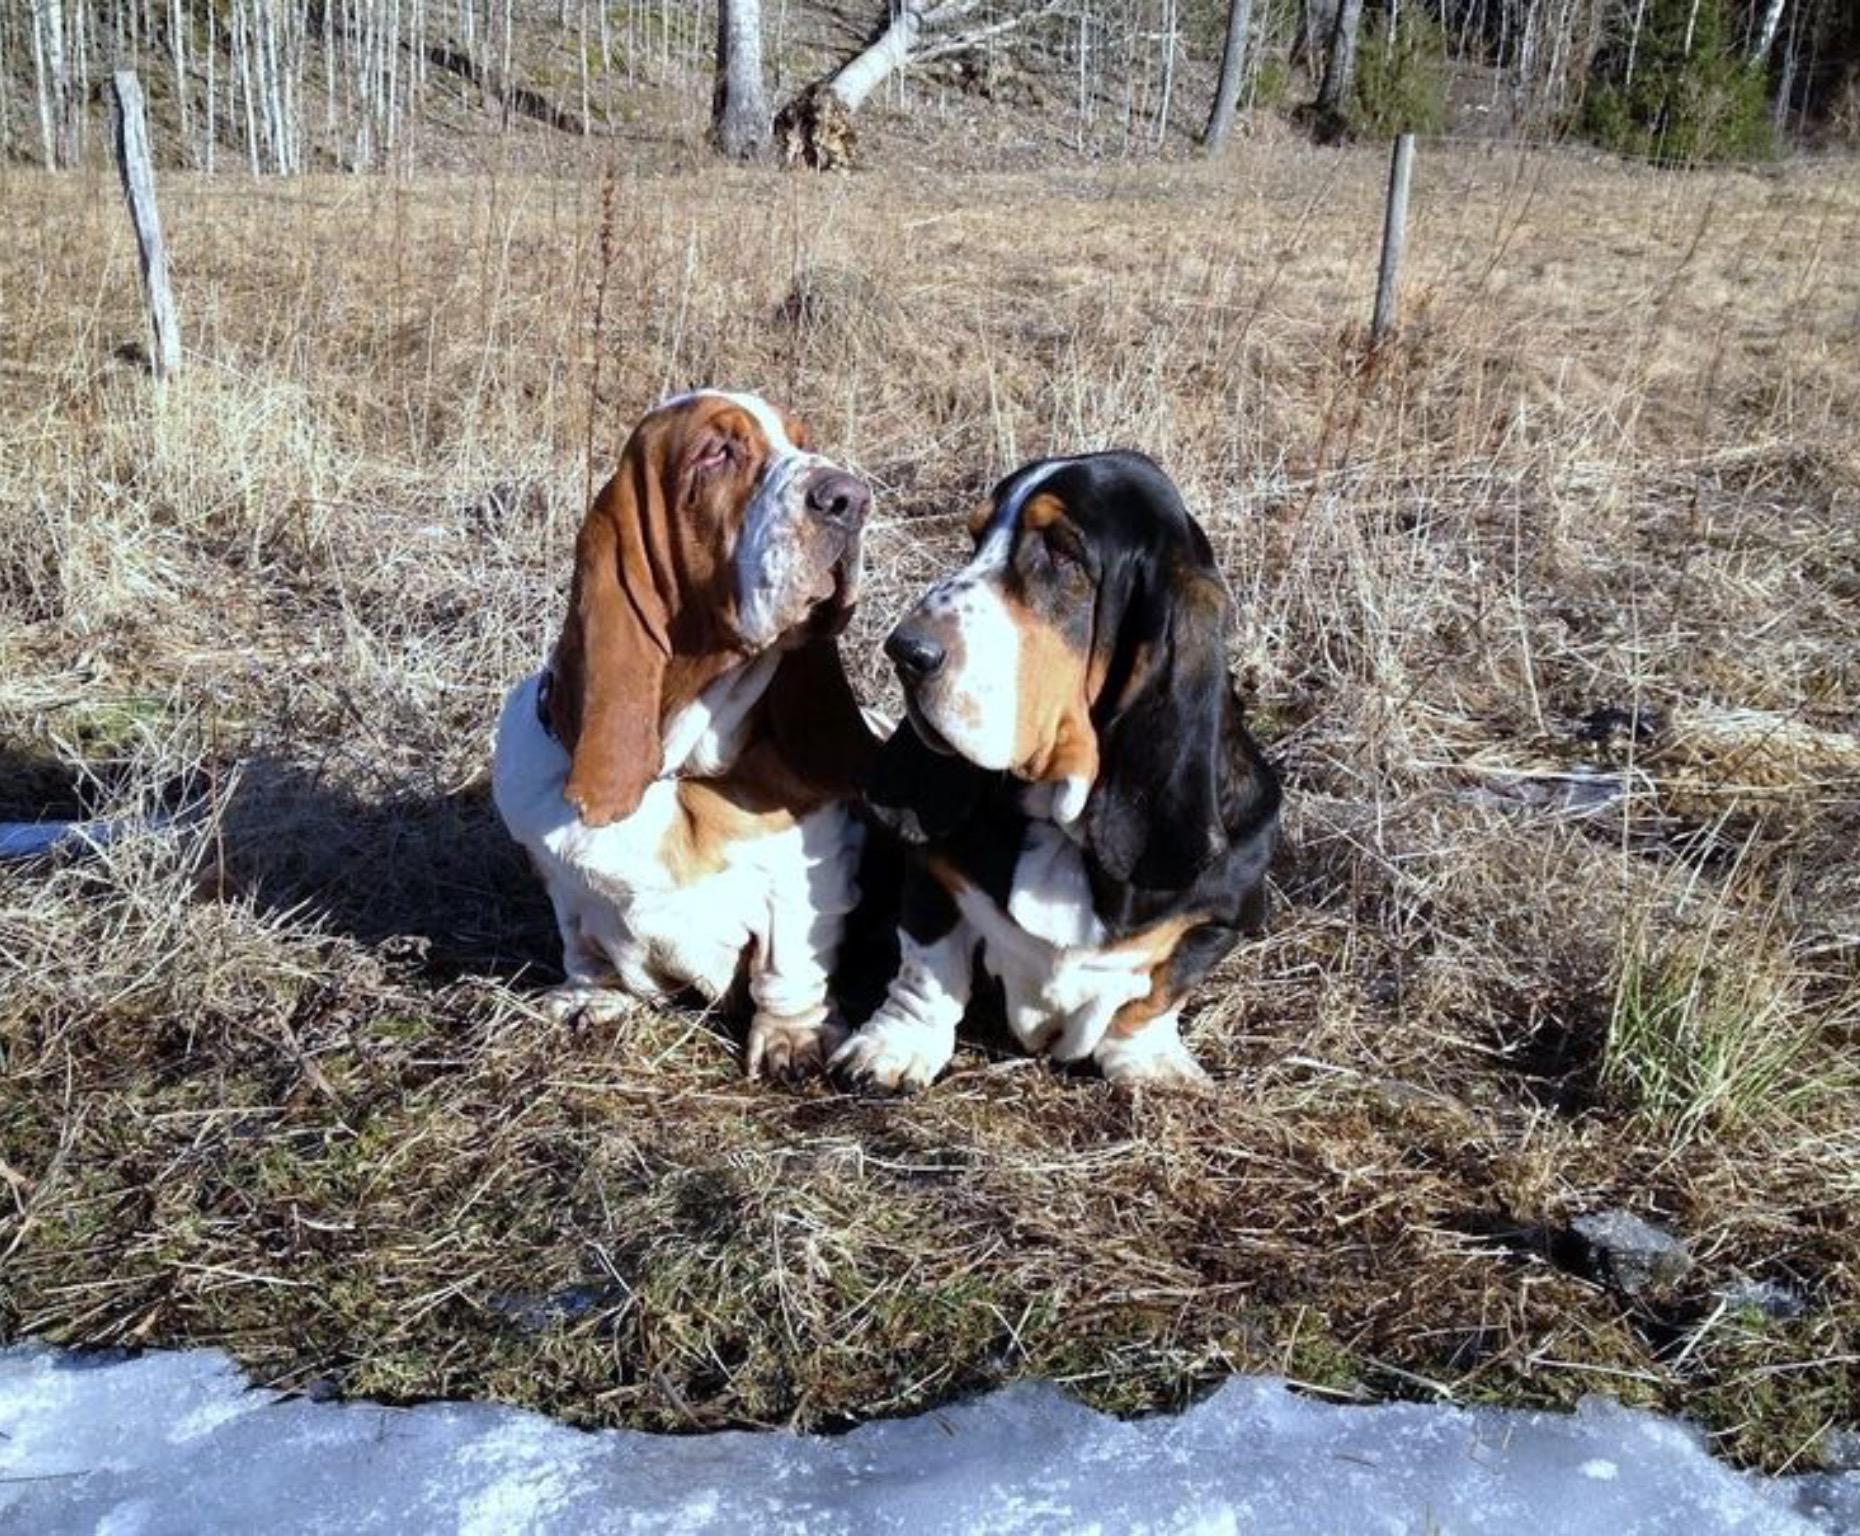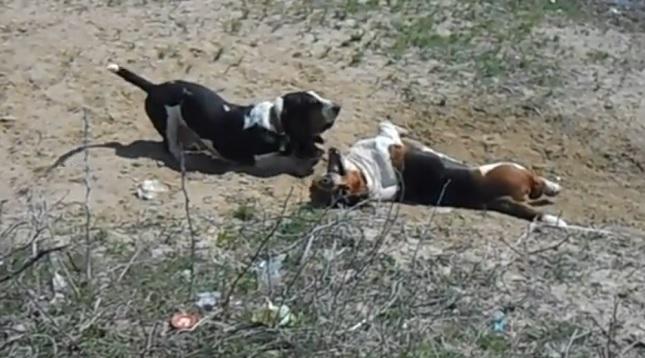The first image is the image on the left, the second image is the image on the right. Assess this claim about the two images: "One image contains two basset hounds and no humans, and the other image includes at least one person with multiple basset hounds on leashes.". Correct or not? Answer yes or no. No. The first image is the image on the left, the second image is the image on the right. For the images shown, is this caption "One picture has atleast 2 dogs and a person." true? Answer yes or no. No. 